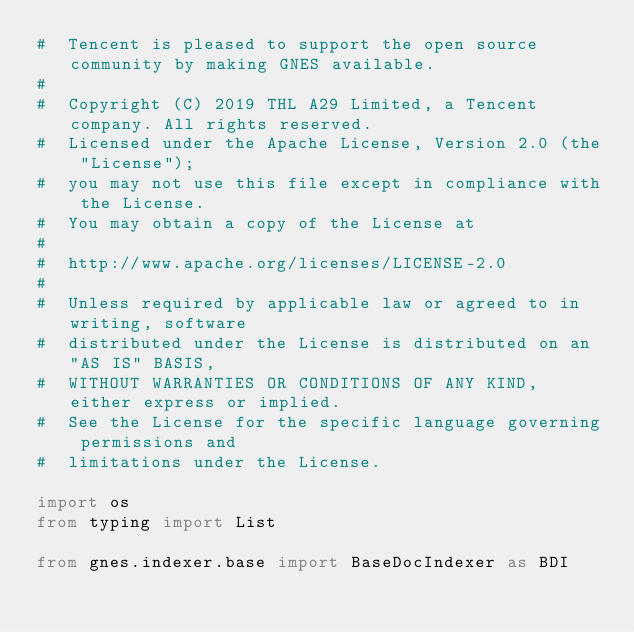Convert code to text. <code><loc_0><loc_0><loc_500><loc_500><_Python_>#  Tencent is pleased to support the open source community by making GNES available.
#
#  Copyright (C) 2019 THL A29 Limited, a Tencent company. All rights reserved.
#  Licensed under the Apache License, Version 2.0 (the "License");
#  you may not use this file except in compliance with the License.
#  You may obtain a copy of the License at
#
#  http://www.apache.org/licenses/LICENSE-2.0
#
#  Unless required by applicable law or agreed to in writing, software
#  distributed under the License is distributed on an "AS IS" BASIS,
#  WITHOUT WARRANTIES OR CONDITIONS OF ANY KIND, either express or implied.
#  See the License for the specific language governing permissions and
#  limitations under the License.

import os
from typing import List

from gnes.indexer.base import BaseDocIndexer as BDI</code> 